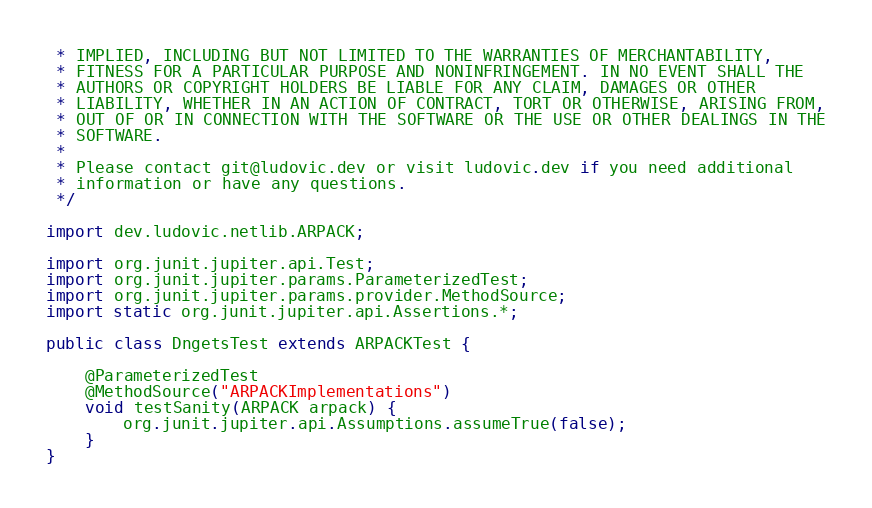Convert code to text. <code><loc_0><loc_0><loc_500><loc_500><_Java_> * IMPLIED, INCLUDING BUT NOT LIMITED TO THE WARRANTIES OF MERCHANTABILITY,
 * FITNESS FOR A PARTICULAR PURPOSE AND NONINFRINGEMENT. IN NO EVENT SHALL THE
 * AUTHORS OR COPYRIGHT HOLDERS BE LIABLE FOR ANY CLAIM, DAMAGES OR OTHER
 * LIABILITY, WHETHER IN AN ACTION OF CONTRACT, TORT OR OTHERWISE, ARISING FROM,
 * OUT OF OR IN CONNECTION WITH THE SOFTWARE OR THE USE OR OTHER DEALINGS IN THE
 * SOFTWARE.
 *
 * Please contact git@ludovic.dev or visit ludovic.dev if you need additional
 * information or have any questions.
 */

import dev.ludovic.netlib.ARPACK;

import org.junit.jupiter.api.Test;
import org.junit.jupiter.params.ParameterizedTest;
import org.junit.jupiter.params.provider.MethodSource;
import static org.junit.jupiter.api.Assertions.*;

public class DngetsTest extends ARPACKTest {

    @ParameterizedTest
    @MethodSource("ARPACKImplementations")
    void testSanity(ARPACK arpack) {
        org.junit.jupiter.api.Assumptions.assumeTrue(false);
    }
}
</code> 